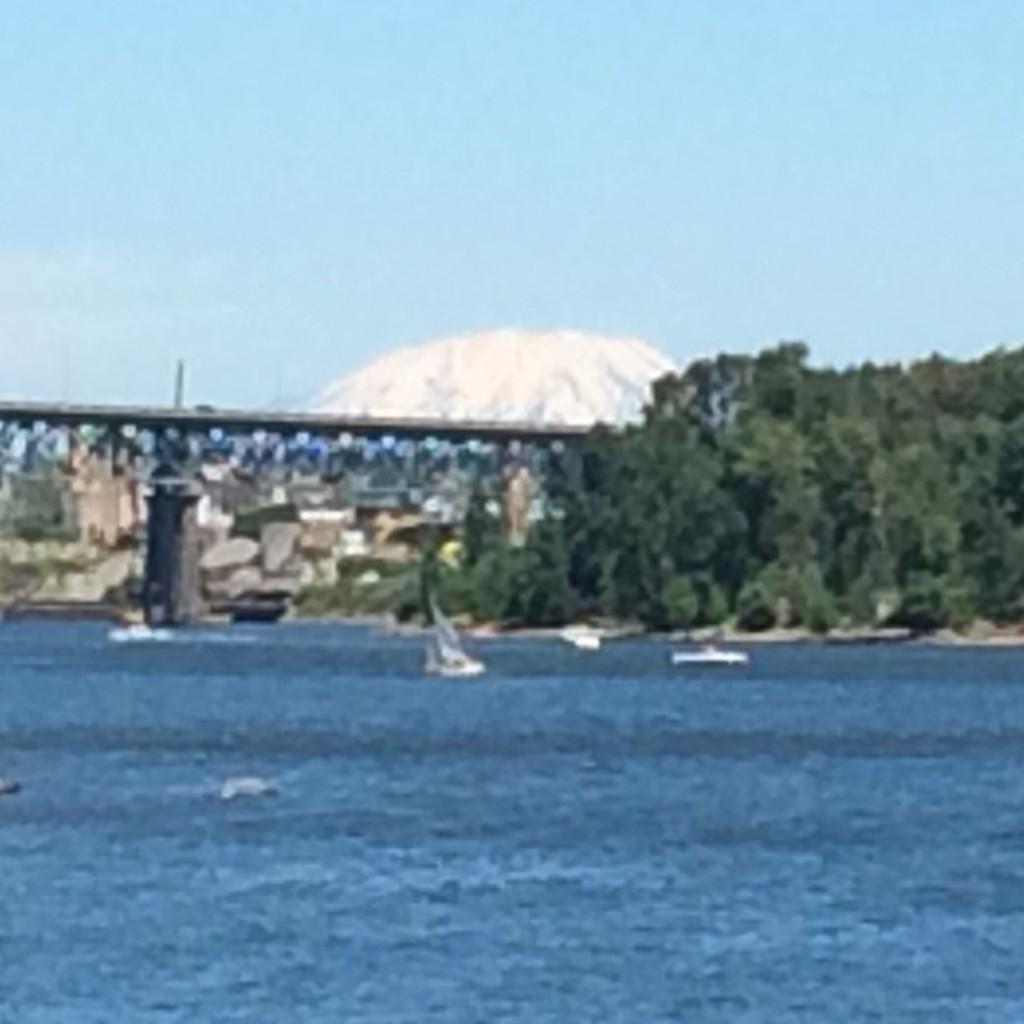Describe this image in one or two sentences. In the picture we can see water which is blue in color in it we can see some boats and far away from it we can see trees and beside it we can see a bridge with a railing to it and behind it we can see rocks and a hill which is covered with snow and a sky behind it. 